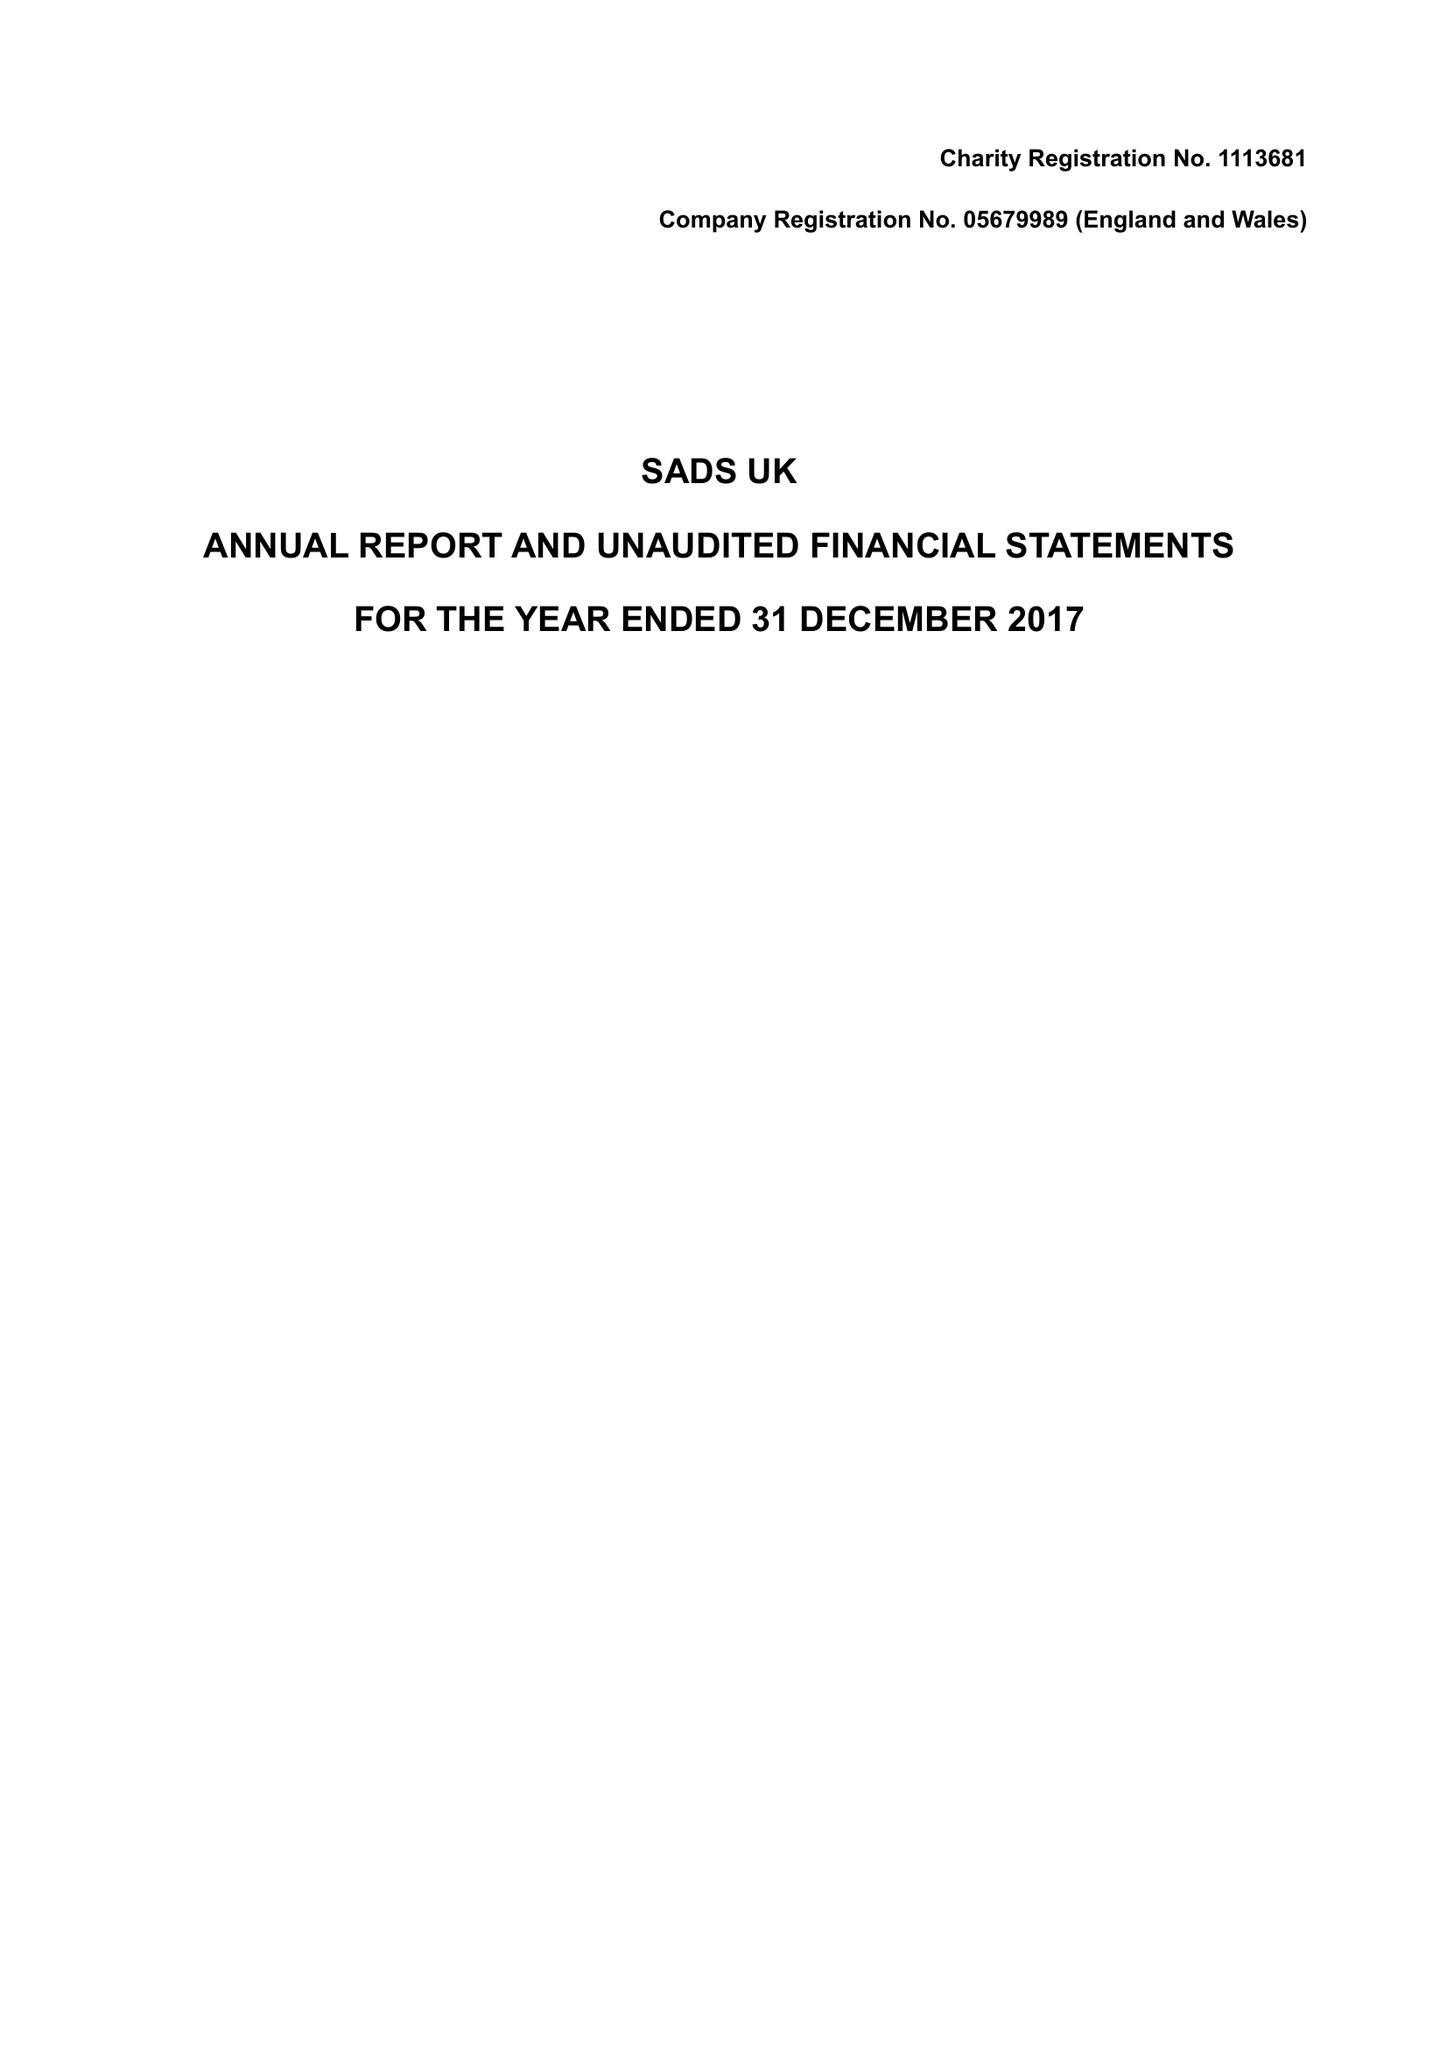What is the value for the charity_name?
Answer the question using a single word or phrase. Sads Uk 